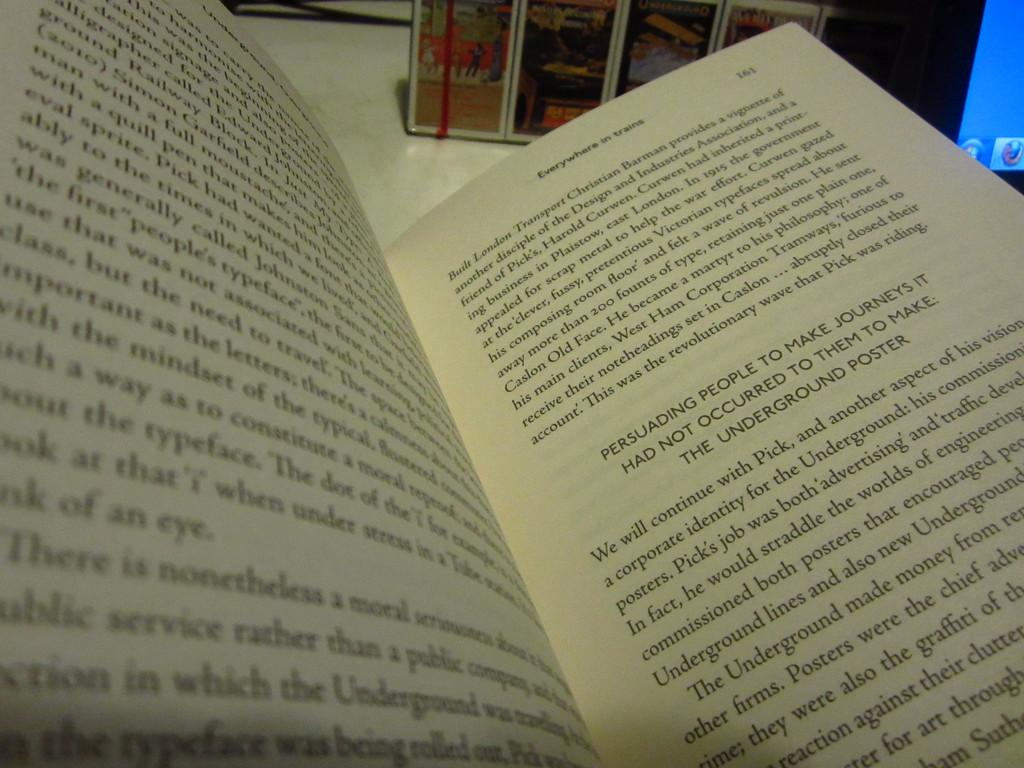Provide a one-sentence caption for the provided image. Open book named Everywhere in trains on page 161. 